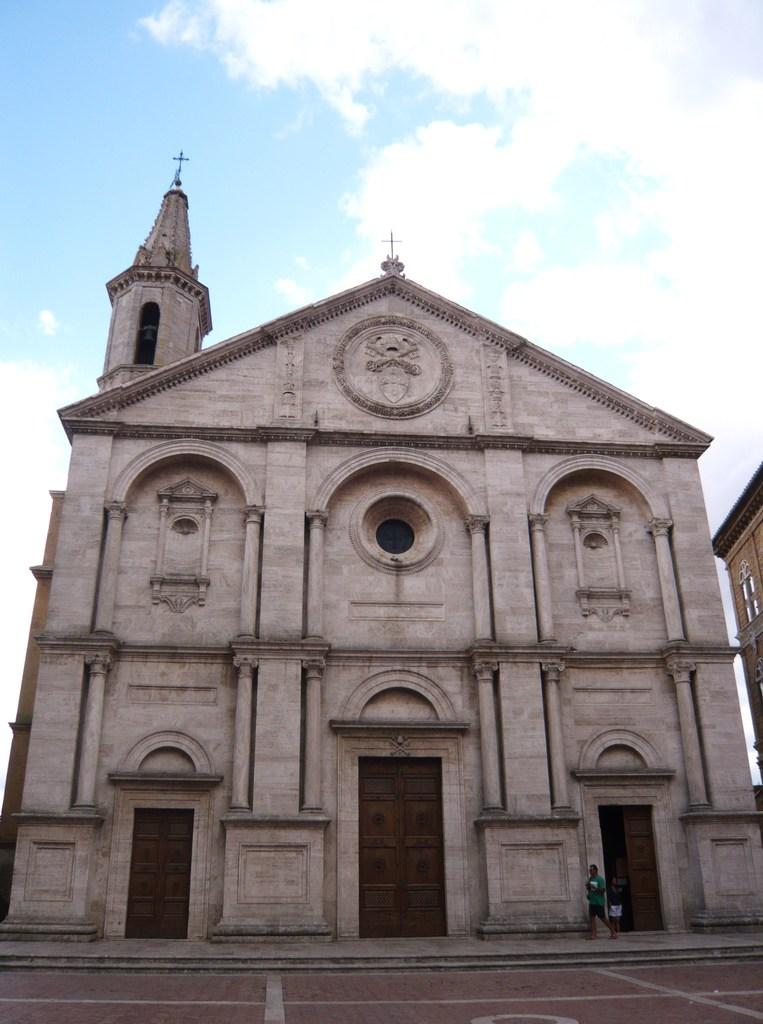What type of structure is visible in the image? There is a building in the image. Are there any people in the image? Yes, there are persons in the image. What feature of the building is visible in the image? There is a door in the image. What else can be seen in the image besides the building and persons? There are other objects in the image. Which side of the image shows the building? The right side of the image appears to show a building. What is visible at the top of the image? The sky is visible at the top of the image. What type of bun is being used to hold the year in the image? There is no bun or year present in the image. What noise can be heard coming from the building in the image? The image does not provide any information about sounds or noises, so it cannot be determined from the image. 